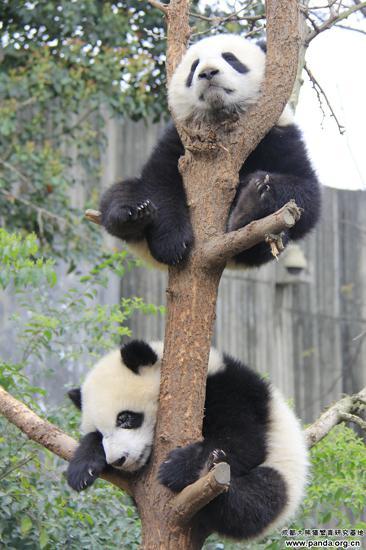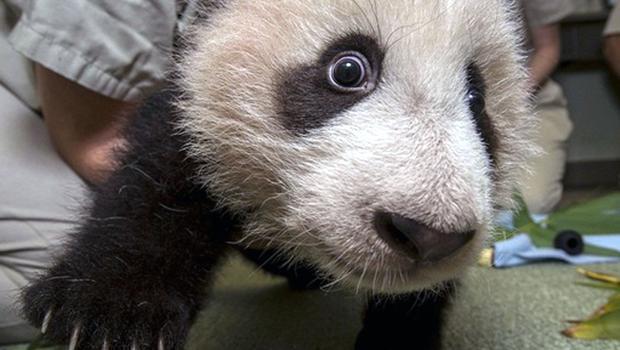The first image is the image on the left, the second image is the image on the right. Considering the images on both sides, is "There are three pandas in total." valid? Answer yes or no. Yes. The first image is the image on the left, the second image is the image on the right. Considering the images on both sides, is "Images show a total of two panda bears relaxing in the branches of leafless trees." valid? Answer yes or no. Yes. 